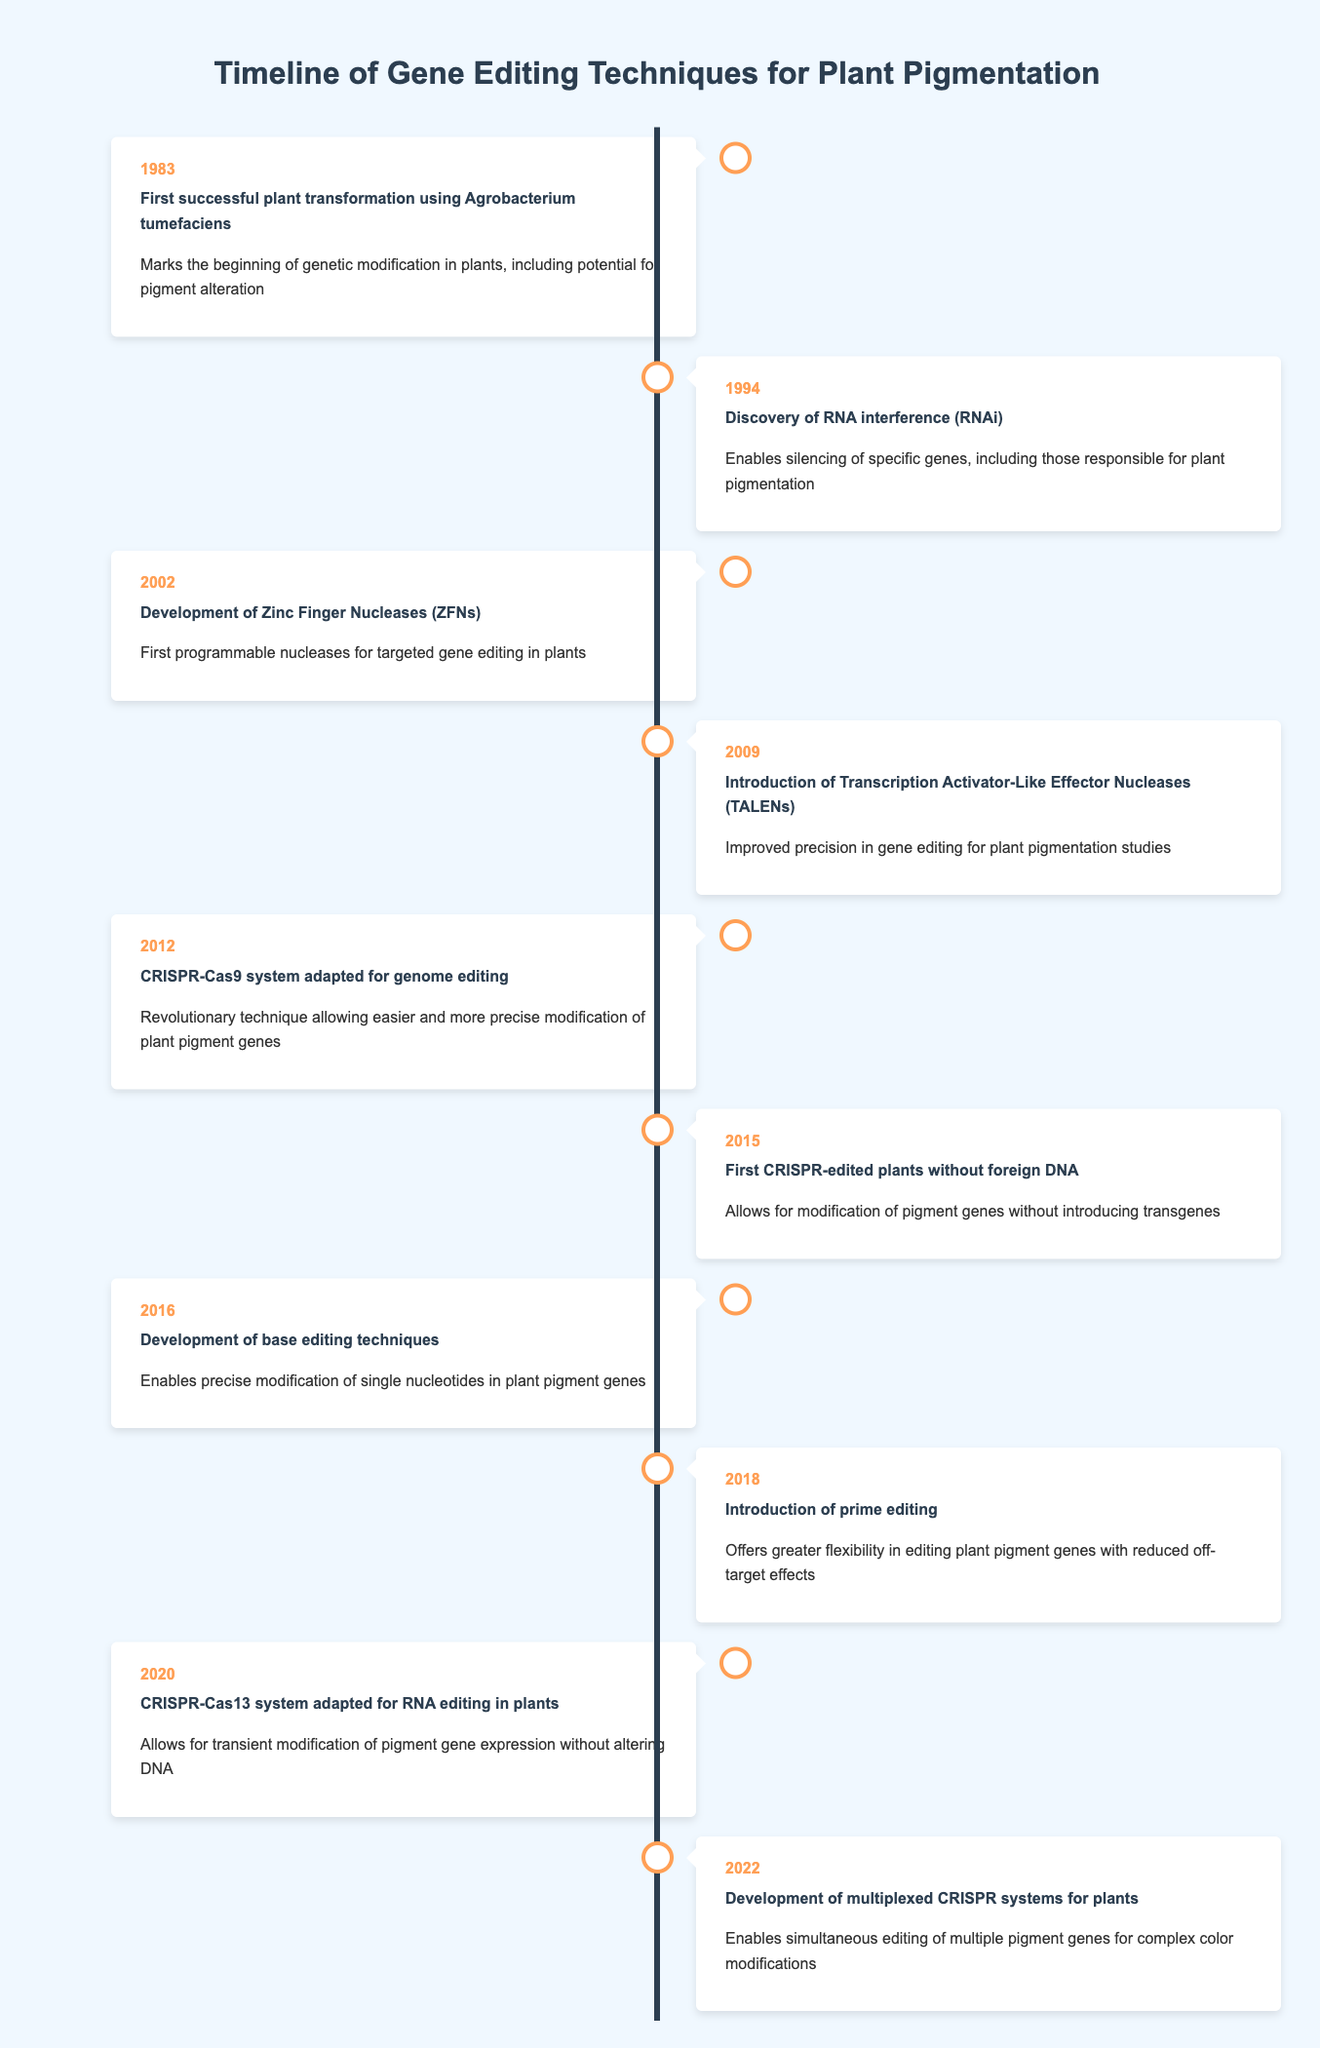What year marked the first successful transformation of plants using Agrobacterium tumefaciens? According to the timeline, the first successful plant transformation using Agrobacterium tumefaciens occurred in 1983.
Answer: 1983 What specific advancement was made in 2016 regarding plant pigments? In 2016, the development of base editing techniques enabled precise modification of single nucleotides in plant pigment genes.
Answer: Base editing techniques Which gene editing technique introduced in 2012 is known for its revolutionary impact on plant pigmentation? The CRISPR-Cas9 system was adapted for genome editing in 2012, which revolutionized the ease and precision of modifying plant pigment genes.
Answer: CRISPR-Cas9 system True or False: The introduction of TALENs occurred before the development of ZFNs. The timeline indicates that ZFNs were developed in 2002, while TALENs were introduced in 2009. Therefore, the statement is false.
Answer: False In what year were the first CRISPR-edited plants created without foreign DNA? What significance does this have for plant pigment modification? The first CRISPR-edited plants without foreign DNA were created in 2015. This is significant because it allows for modification of pigment genes without introducing transgenes, making the process more natural.
Answer: 2015, significant reduction of transgenes What is the chronological difference between the discovery of RNA interference and the introduction of prime editing? RNA interference was discovered in 1994, while prime editing was introduced in 2018. The chronological difference is 2018 - 1994 = 24 years.
Answer: 24 years Which technique, introduced in 2022, allows for simultaneous editing of multiple pigment genes and is noted for complex color modifications in plants? The multiplexed CRISPR systems, developed in 2022, enable simultaneous editing of multiple pigment genes for intricate color modifications.
Answer: Multiplexed CRISPR systems What is the primary advantage of the CRISPR-Cas13 system adapted in 2020 for plant pigments? The CRISPR-Cas13 system allows for transient modification of pigment gene expression without altering the DNA, making it a flexible editing option.
Answer: Transient modification without DNA alteration What year did the most recent advancement in gene editing techniques for modifying plant pigmentation occur, and what was its focus? The most recent advancement occurred in 2022, focusing on the development of multiplexed CRISPR systems for simultaneous editing of pigment genes.
Answer: 2022, multiplexed CRISPR systems 